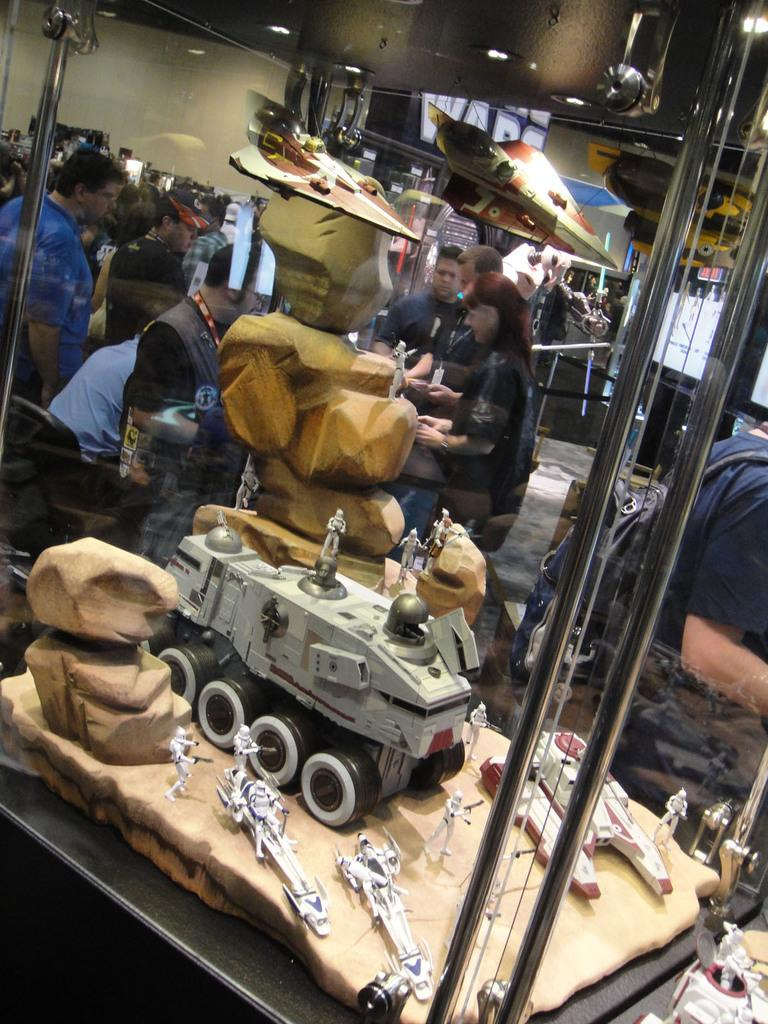What is happening in the image? There is a group of people standing in the image. What can be seen in the foreground of the image? In the foreground of the image, there are toys inside a glass door. What is visible in the background of the image? In the background of the image, there is a plane and some lights. What type of jewel is the passenger holding in the image? There is no passenger or jewel present in the image. What type of work are the people in the image engaged in? The image does not provide information about the people's work or occupation. 